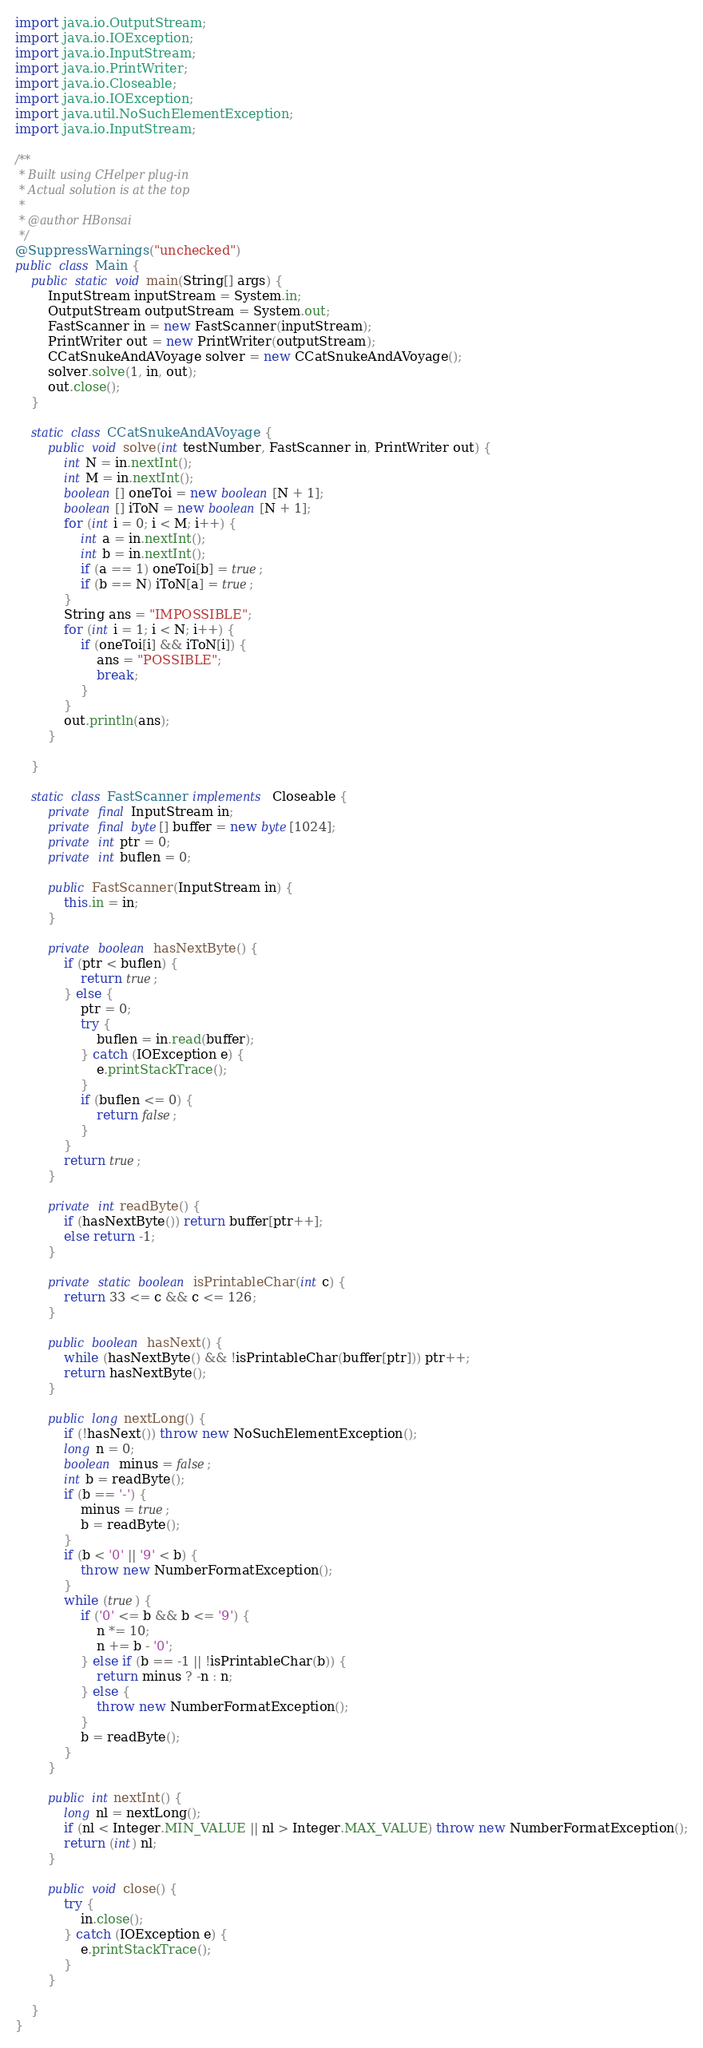Convert code to text. <code><loc_0><loc_0><loc_500><loc_500><_Java_>import java.io.OutputStream;
import java.io.IOException;
import java.io.InputStream;
import java.io.PrintWriter;
import java.io.Closeable;
import java.io.IOException;
import java.util.NoSuchElementException;
import java.io.InputStream;

/**
 * Built using CHelper plug-in
 * Actual solution is at the top
 *
 * @author HBonsai
 */
@SuppressWarnings("unchecked")
public class Main {
    public static void main(String[] args) {
        InputStream inputStream = System.in;
        OutputStream outputStream = System.out;
        FastScanner in = new FastScanner(inputStream);
        PrintWriter out = new PrintWriter(outputStream);
        CCatSnukeAndAVoyage solver = new CCatSnukeAndAVoyage();
        solver.solve(1, in, out);
        out.close();
    }

    static class CCatSnukeAndAVoyage {
        public void solve(int testNumber, FastScanner in, PrintWriter out) {
            int N = in.nextInt();
            int M = in.nextInt();
            boolean[] oneToi = new boolean[N + 1];
            boolean[] iToN = new boolean[N + 1];
            for (int i = 0; i < M; i++) {
                int a = in.nextInt();
                int b = in.nextInt();
                if (a == 1) oneToi[b] = true;
                if (b == N) iToN[a] = true;
            }
            String ans = "IMPOSSIBLE";
            for (int i = 1; i < N; i++) {
                if (oneToi[i] && iToN[i]) {
                    ans = "POSSIBLE";
                    break;
                }
            }
            out.println(ans);
        }

    }

    static class FastScanner implements Closeable {
        private final InputStream in;
        private final byte[] buffer = new byte[1024];
        private int ptr = 0;
        private int buflen = 0;

        public FastScanner(InputStream in) {
            this.in = in;
        }

        private boolean hasNextByte() {
            if (ptr < buflen) {
                return true;
            } else {
                ptr = 0;
                try {
                    buflen = in.read(buffer);
                } catch (IOException e) {
                    e.printStackTrace();
                }
                if (buflen <= 0) {
                    return false;
                }
            }
            return true;
        }

        private int readByte() {
            if (hasNextByte()) return buffer[ptr++];
            else return -1;
        }

        private static boolean isPrintableChar(int c) {
            return 33 <= c && c <= 126;
        }

        public boolean hasNext() {
            while (hasNextByte() && !isPrintableChar(buffer[ptr])) ptr++;
            return hasNextByte();
        }

        public long nextLong() {
            if (!hasNext()) throw new NoSuchElementException();
            long n = 0;
            boolean minus = false;
            int b = readByte();
            if (b == '-') {
                minus = true;
                b = readByte();
            }
            if (b < '0' || '9' < b) {
                throw new NumberFormatException();
            }
            while (true) {
                if ('0' <= b && b <= '9') {
                    n *= 10;
                    n += b - '0';
                } else if (b == -1 || !isPrintableChar(b)) {
                    return minus ? -n : n;
                } else {
                    throw new NumberFormatException();
                }
                b = readByte();
            }
        }

        public int nextInt() {
            long nl = nextLong();
            if (nl < Integer.MIN_VALUE || nl > Integer.MAX_VALUE) throw new NumberFormatException();
            return (int) nl;
        }

        public void close() {
            try {
                in.close();
            } catch (IOException e) {
                e.printStackTrace();
            }
        }

    }
}

</code> 